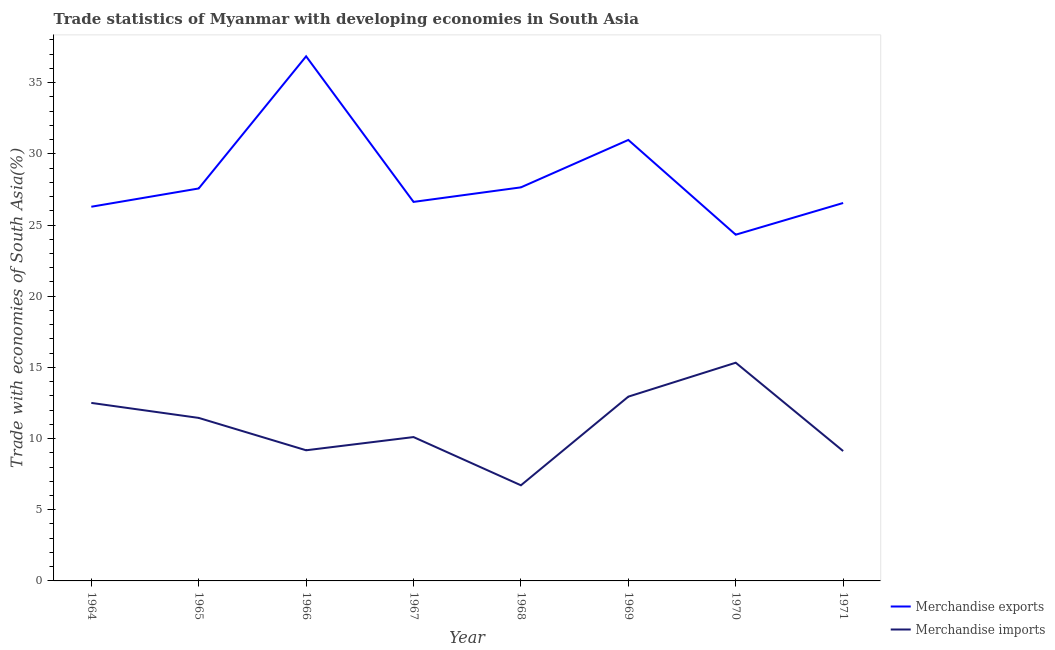How many different coloured lines are there?
Your response must be concise. 2. What is the merchandise exports in 1964?
Make the answer very short. 26.29. Across all years, what is the maximum merchandise exports?
Provide a short and direct response. 36.85. Across all years, what is the minimum merchandise exports?
Offer a very short reply. 24.32. In which year was the merchandise exports maximum?
Make the answer very short. 1966. In which year was the merchandise imports minimum?
Ensure brevity in your answer.  1968. What is the total merchandise exports in the graph?
Give a very brief answer. 226.82. What is the difference between the merchandise exports in 1965 and that in 1970?
Your response must be concise. 3.25. What is the difference between the merchandise imports in 1971 and the merchandise exports in 1964?
Your answer should be compact. -17.16. What is the average merchandise exports per year?
Your answer should be very brief. 28.35. In the year 1969, what is the difference between the merchandise imports and merchandise exports?
Your answer should be compact. -18.03. In how many years, is the merchandise imports greater than 4 %?
Ensure brevity in your answer.  8. What is the ratio of the merchandise exports in 1965 to that in 1969?
Offer a terse response. 0.89. What is the difference between the highest and the second highest merchandise imports?
Provide a short and direct response. 2.38. What is the difference between the highest and the lowest merchandise exports?
Offer a very short reply. 12.53. Does the merchandise exports monotonically increase over the years?
Ensure brevity in your answer.  No. Is the merchandise exports strictly greater than the merchandise imports over the years?
Your response must be concise. Yes. How many lines are there?
Give a very brief answer. 2. How many years are there in the graph?
Your answer should be very brief. 8. What is the difference between two consecutive major ticks on the Y-axis?
Provide a succinct answer. 5. Are the values on the major ticks of Y-axis written in scientific E-notation?
Your answer should be very brief. No. Where does the legend appear in the graph?
Keep it short and to the point. Bottom right. What is the title of the graph?
Offer a very short reply. Trade statistics of Myanmar with developing economies in South Asia. What is the label or title of the X-axis?
Your answer should be compact. Year. What is the label or title of the Y-axis?
Your answer should be very brief. Trade with economies of South Asia(%). What is the Trade with economies of South Asia(%) of Merchandise exports in 1964?
Give a very brief answer. 26.29. What is the Trade with economies of South Asia(%) of Merchandise imports in 1964?
Give a very brief answer. 12.5. What is the Trade with economies of South Asia(%) in Merchandise exports in 1965?
Offer a terse response. 27.57. What is the Trade with economies of South Asia(%) of Merchandise imports in 1965?
Keep it short and to the point. 11.45. What is the Trade with economies of South Asia(%) in Merchandise exports in 1966?
Offer a terse response. 36.85. What is the Trade with economies of South Asia(%) in Merchandise imports in 1966?
Your answer should be very brief. 9.18. What is the Trade with economies of South Asia(%) of Merchandise exports in 1967?
Your answer should be very brief. 26.62. What is the Trade with economies of South Asia(%) in Merchandise imports in 1967?
Your answer should be compact. 10.11. What is the Trade with economies of South Asia(%) in Merchandise exports in 1968?
Your response must be concise. 27.65. What is the Trade with economies of South Asia(%) of Merchandise imports in 1968?
Your answer should be very brief. 6.72. What is the Trade with economies of South Asia(%) of Merchandise exports in 1969?
Your answer should be compact. 30.98. What is the Trade with economies of South Asia(%) in Merchandise imports in 1969?
Your answer should be very brief. 12.94. What is the Trade with economies of South Asia(%) of Merchandise exports in 1970?
Ensure brevity in your answer.  24.32. What is the Trade with economies of South Asia(%) in Merchandise imports in 1970?
Offer a terse response. 15.33. What is the Trade with economies of South Asia(%) in Merchandise exports in 1971?
Provide a short and direct response. 26.55. What is the Trade with economies of South Asia(%) in Merchandise imports in 1971?
Give a very brief answer. 9.12. Across all years, what is the maximum Trade with economies of South Asia(%) of Merchandise exports?
Provide a short and direct response. 36.85. Across all years, what is the maximum Trade with economies of South Asia(%) of Merchandise imports?
Offer a terse response. 15.33. Across all years, what is the minimum Trade with economies of South Asia(%) of Merchandise exports?
Offer a very short reply. 24.32. Across all years, what is the minimum Trade with economies of South Asia(%) of Merchandise imports?
Provide a short and direct response. 6.72. What is the total Trade with economies of South Asia(%) in Merchandise exports in the graph?
Give a very brief answer. 226.82. What is the total Trade with economies of South Asia(%) of Merchandise imports in the graph?
Offer a terse response. 87.35. What is the difference between the Trade with economies of South Asia(%) of Merchandise exports in 1964 and that in 1965?
Provide a short and direct response. -1.28. What is the difference between the Trade with economies of South Asia(%) in Merchandise imports in 1964 and that in 1965?
Your answer should be compact. 1.05. What is the difference between the Trade with economies of South Asia(%) in Merchandise exports in 1964 and that in 1966?
Make the answer very short. -10.57. What is the difference between the Trade with economies of South Asia(%) of Merchandise imports in 1964 and that in 1966?
Your answer should be very brief. 3.33. What is the difference between the Trade with economies of South Asia(%) of Merchandise exports in 1964 and that in 1967?
Your answer should be very brief. -0.34. What is the difference between the Trade with economies of South Asia(%) of Merchandise imports in 1964 and that in 1967?
Provide a short and direct response. 2.4. What is the difference between the Trade with economies of South Asia(%) in Merchandise exports in 1964 and that in 1968?
Give a very brief answer. -1.36. What is the difference between the Trade with economies of South Asia(%) of Merchandise imports in 1964 and that in 1968?
Offer a terse response. 5.79. What is the difference between the Trade with economies of South Asia(%) of Merchandise exports in 1964 and that in 1969?
Ensure brevity in your answer.  -4.69. What is the difference between the Trade with economies of South Asia(%) of Merchandise imports in 1964 and that in 1969?
Offer a very short reply. -0.44. What is the difference between the Trade with economies of South Asia(%) in Merchandise exports in 1964 and that in 1970?
Ensure brevity in your answer.  1.96. What is the difference between the Trade with economies of South Asia(%) of Merchandise imports in 1964 and that in 1970?
Ensure brevity in your answer.  -2.82. What is the difference between the Trade with economies of South Asia(%) in Merchandise exports in 1964 and that in 1971?
Make the answer very short. -0.26. What is the difference between the Trade with economies of South Asia(%) in Merchandise imports in 1964 and that in 1971?
Your answer should be very brief. 3.38. What is the difference between the Trade with economies of South Asia(%) of Merchandise exports in 1965 and that in 1966?
Make the answer very short. -9.28. What is the difference between the Trade with economies of South Asia(%) in Merchandise imports in 1965 and that in 1966?
Keep it short and to the point. 2.27. What is the difference between the Trade with economies of South Asia(%) in Merchandise exports in 1965 and that in 1967?
Keep it short and to the point. 0.94. What is the difference between the Trade with economies of South Asia(%) of Merchandise imports in 1965 and that in 1967?
Provide a short and direct response. 1.35. What is the difference between the Trade with economies of South Asia(%) in Merchandise exports in 1965 and that in 1968?
Your answer should be compact. -0.08. What is the difference between the Trade with economies of South Asia(%) of Merchandise imports in 1965 and that in 1968?
Make the answer very short. 4.73. What is the difference between the Trade with economies of South Asia(%) in Merchandise exports in 1965 and that in 1969?
Ensure brevity in your answer.  -3.41. What is the difference between the Trade with economies of South Asia(%) of Merchandise imports in 1965 and that in 1969?
Provide a succinct answer. -1.49. What is the difference between the Trade with economies of South Asia(%) of Merchandise exports in 1965 and that in 1970?
Make the answer very short. 3.25. What is the difference between the Trade with economies of South Asia(%) of Merchandise imports in 1965 and that in 1970?
Offer a terse response. -3.88. What is the difference between the Trade with economies of South Asia(%) of Merchandise exports in 1965 and that in 1971?
Make the answer very short. 1.02. What is the difference between the Trade with economies of South Asia(%) of Merchandise imports in 1965 and that in 1971?
Give a very brief answer. 2.33. What is the difference between the Trade with economies of South Asia(%) in Merchandise exports in 1966 and that in 1967?
Offer a very short reply. 10.23. What is the difference between the Trade with economies of South Asia(%) in Merchandise imports in 1966 and that in 1967?
Your answer should be compact. -0.93. What is the difference between the Trade with economies of South Asia(%) in Merchandise exports in 1966 and that in 1968?
Provide a short and direct response. 9.2. What is the difference between the Trade with economies of South Asia(%) of Merchandise imports in 1966 and that in 1968?
Give a very brief answer. 2.46. What is the difference between the Trade with economies of South Asia(%) of Merchandise exports in 1966 and that in 1969?
Provide a succinct answer. 5.87. What is the difference between the Trade with economies of South Asia(%) in Merchandise imports in 1966 and that in 1969?
Keep it short and to the point. -3.77. What is the difference between the Trade with economies of South Asia(%) in Merchandise exports in 1966 and that in 1970?
Make the answer very short. 12.53. What is the difference between the Trade with economies of South Asia(%) in Merchandise imports in 1966 and that in 1970?
Your response must be concise. -6.15. What is the difference between the Trade with economies of South Asia(%) of Merchandise exports in 1966 and that in 1971?
Provide a short and direct response. 10.3. What is the difference between the Trade with economies of South Asia(%) in Merchandise imports in 1966 and that in 1971?
Your response must be concise. 0.05. What is the difference between the Trade with economies of South Asia(%) of Merchandise exports in 1967 and that in 1968?
Your answer should be very brief. -1.02. What is the difference between the Trade with economies of South Asia(%) of Merchandise imports in 1967 and that in 1968?
Your response must be concise. 3.39. What is the difference between the Trade with economies of South Asia(%) of Merchandise exports in 1967 and that in 1969?
Offer a terse response. -4.35. What is the difference between the Trade with economies of South Asia(%) of Merchandise imports in 1967 and that in 1969?
Keep it short and to the point. -2.84. What is the difference between the Trade with economies of South Asia(%) in Merchandise exports in 1967 and that in 1970?
Make the answer very short. 2.3. What is the difference between the Trade with economies of South Asia(%) of Merchandise imports in 1967 and that in 1970?
Give a very brief answer. -5.22. What is the difference between the Trade with economies of South Asia(%) of Merchandise exports in 1967 and that in 1971?
Provide a short and direct response. 0.08. What is the difference between the Trade with economies of South Asia(%) of Merchandise imports in 1967 and that in 1971?
Your answer should be compact. 0.98. What is the difference between the Trade with economies of South Asia(%) of Merchandise exports in 1968 and that in 1969?
Offer a terse response. -3.33. What is the difference between the Trade with economies of South Asia(%) of Merchandise imports in 1968 and that in 1969?
Keep it short and to the point. -6.23. What is the difference between the Trade with economies of South Asia(%) in Merchandise exports in 1968 and that in 1970?
Your response must be concise. 3.33. What is the difference between the Trade with economies of South Asia(%) in Merchandise imports in 1968 and that in 1970?
Offer a very short reply. -8.61. What is the difference between the Trade with economies of South Asia(%) of Merchandise exports in 1968 and that in 1971?
Keep it short and to the point. 1.1. What is the difference between the Trade with economies of South Asia(%) in Merchandise imports in 1968 and that in 1971?
Keep it short and to the point. -2.41. What is the difference between the Trade with economies of South Asia(%) in Merchandise exports in 1969 and that in 1970?
Give a very brief answer. 6.66. What is the difference between the Trade with economies of South Asia(%) in Merchandise imports in 1969 and that in 1970?
Your response must be concise. -2.38. What is the difference between the Trade with economies of South Asia(%) of Merchandise exports in 1969 and that in 1971?
Your response must be concise. 4.43. What is the difference between the Trade with economies of South Asia(%) of Merchandise imports in 1969 and that in 1971?
Give a very brief answer. 3.82. What is the difference between the Trade with economies of South Asia(%) in Merchandise exports in 1970 and that in 1971?
Give a very brief answer. -2.23. What is the difference between the Trade with economies of South Asia(%) of Merchandise imports in 1970 and that in 1971?
Your answer should be very brief. 6.21. What is the difference between the Trade with economies of South Asia(%) in Merchandise exports in 1964 and the Trade with economies of South Asia(%) in Merchandise imports in 1965?
Provide a succinct answer. 14.83. What is the difference between the Trade with economies of South Asia(%) of Merchandise exports in 1964 and the Trade with economies of South Asia(%) of Merchandise imports in 1966?
Ensure brevity in your answer.  17.11. What is the difference between the Trade with economies of South Asia(%) of Merchandise exports in 1964 and the Trade with economies of South Asia(%) of Merchandise imports in 1967?
Provide a succinct answer. 16.18. What is the difference between the Trade with economies of South Asia(%) in Merchandise exports in 1964 and the Trade with economies of South Asia(%) in Merchandise imports in 1968?
Your response must be concise. 19.57. What is the difference between the Trade with economies of South Asia(%) in Merchandise exports in 1964 and the Trade with economies of South Asia(%) in Merchandise imports in 1969?
Offer a terse response. 13.34. What is the difference between the Trade with economies of South Asia(%) in Merchandise exports in 1964 and the Trade with economies of South Asia(%) in Merchandise imports in 1970?
Make the answer very short. 10.96. What is the difference between the Trade with economies of South Asia(%) in Merchandise exports in 1964 and the Trade with economies of South Asia(%) in Merchandise imports in 1971?
Make the answer very short. 17.16. What is the difference between the Trade with economies of South Asia(%) in Merchandise exports in 1965 and the Trade with economies of South Asia(%) in Merchandise imports in 1966?
Provide a succinct answer. 18.39. What is the difference between the Trade with economies of South Asia(%) of Merchandise exports in 1965 and the Trade with economies of South Asia(%) of Merchandise imports in 1967?
Offer a very short reply. 17.46. What is the difference between the Trade with economies of South Asia(%) of Merchandise exports in 1965 and the Trade with economies of South Asia(%) of Merchandise imports in 1968?
Your answer should be compact. 20.85. What is the difference between the Trade with economies of South Asia(%) in Merchandise exports in 1965 and the Trade with economies of South Asia(%) in Merchandise imports in 1969?
Offer a terse response. 14.62. What is the difference between the Trade with economies of South Asia(%) in Merchandise exports in 1965 and the Trade with economies of South Asia(%) in Merchandise imports in 1970?
Provide a succinct answer. 12.24. What is the difference between the Trade with economies of South Asia(%) of Merchandise exports in 1965 and the Trade with economies of South Asia(%) of Merchandise imports in 1971?
Offer a very short reply. 18.45. What is the difference between the Trade with economies of South Asia(%) of Merchandise exports in 1966 and the Trade with economies of South Asia(%) of Merchandise imports in 1967?
Ensure brevity in your answer.  26.75. What is the difference between the Trade with economies of South Asia(%) of Merchandise exports in 1966 and the Trade with economies of South Asia(%) of Merchandise imports in 1968?
Ensure brevity in your answer.  30.13. What is the difference between the Trade with economies of South Asia(%) of Merchandise exports in 1966 and the Trade with economies of South Asia(%) of Merchandise imports in 1969?
Offer a terse response. 23.91. What is the difference between the Trade with economies of South Asia(%) in Merchandise exports in 1966 and the Trade with economies of South Asia(%) in Merchandise imports in 1970?
Your answer should be compact. 21.52. What is the difference between the Trade with economies of South Asia(%) of Merchandise exports in 1966 and the Trade with economies of South Asia(%) of Merchandise imports in 1971?
Give a very brief answer. 27.73. What is the difference between the Trade with economies of South Asia(%) of Merchandise exports in 1967 and the Trade with economies of South Asia(%) of Merchandise imports in 1968?
Your response must be concise. 19.91. What is the difference between the Trade with economies of South Asia(%) in Merchandise exports in 1967 and the Trade with economies of South Asia(%) in Merchandise imports in 1969?
Provide a short and direct response. 13.68. What is the difference between the Trade with economies of South Asia(%) in Merchandise exports in 1967 and the Trade with economies of South Asia(%) in Merchandise imports in 1970?
Offer a very short reply. 11.3. What is the difference between the Trade with economies of South Asia(%) in Merchandise exports in 1967 and the Trade with economies of South Asia(%) in Merchandise imports in 1971?
Your answer should be compact. 17.5. What is the difference between the Trade with economies of South Asia(%) of Merchandise exports in 1968 and the Trade with economies of South Asia(%) of Merchandise imports in 1969?
Provide a short and direct response. 14.7. What is the difference between the Trade with economies of South Asia(%) in Merchandise exports in 1968 and the Trade with economies of South Asia(%) in Merchandise imports in 1970?
Make the answer very short. 12.32. What is the difference between the Trade with economies of South Asia(%) of Merchandise exports in 1968 and the Trade with economies of South Asia(%) of Merchandise imports in 1971?
Give a very brief answer. 18.52. What is the difference between the Trade with economies of South Asia(%) in Merchandise exports in 1969 and the Trade with economies of South Asia(%) in Merchandise imports in 1970?
Your answer should be very brief. 15.65. What is the difference between the Trade with economies of South Asia(%) of Merchandise exports in 1969 and the Trade with economies of South Asia(%) of Merchandise imports in 1971?
Make the answer very short. 21.85. What is the difference between the Trade with economies of South Asia(%) of Merchandise exports in 1970 and the Trade with economies of South Asia(%) of Merchandise imports in 1971?
Your answer should be compact. 15.2. What is the average Trade with economies of South Asia(%) in Merchandise exports per year?
Give a very brief answer. 28.35. What is the average Trade with economies of South Asia(%) of Merchandise imports per year?
Your answer should be compact. 10.92. In the year 1964, what is the difference between the Trade with economies of South Asia(%) of Merchandise exports and Trade with economies of South Asia(%) of Merchandise imports?
Keep it short and to the point. 13.78. In the year 1965, what is the difference between the Trade with economies of South Asia(%) of Merchandise exports and Trade with economies of South Asia(%) of Merchandise imports?
Provide a short and direct response. 16.12. In the year 1966, what is the difference between the Trade with economies of South Asia(%) of Merchandise exports and Trade with economies of South Asia(%) of Merchandise imports?
Offer a very short reply. 27.67. In the year 1967, what is the difference between the Trade with economies of South Asia(%) of Merchandise exports and Trade with economies of South Asia(%) of Merchandise imports?
Your answer should be compact. 16.52. In the year 1968, what is the difference between the Trade with economies of South Asia(%) of Merchandise exports and Trade with economies of South Asia(%) of Merchandise imports?
Provide a short and direct response. 20.93. In the year 1969, what is the difference between the Trade with economies of South Asia(%) in Merchandise exports and Trade with economies of South Asia(%) in Merchandise imports?
Your answer should be very brief. 18.03. In the year 1970, what is the difference between the Trade with economies of South Asia(%) of Merchandise exports and Trade with economies of South Asia(%) of Merchandise imports?
Ensure brevity in your answer.  8.99. In the year 1971, what is the difference between the Trade with economies of South Asia(%) of Merchandise exports and Trade with economies of South Asia(%) of Merchandise imports?
Keep it short and to the point. 17.42. What is the ratio of the Trade with economies of South Asia(%) in Merchandise exports in 1964 to that in 1965?
Keep it short and to the point. 0.95. What is the ratio of the Trade with economies of South Asia(%) of Merchandise imports in 1964 to that in 1965?
Make the answer very short. 1.09. What is the ratio of the Trade with economies of South Asia(%) in Merchandise exports in 1964 to that in 1966?
Keep it short and to the point. 0.71. What is the ratio of the Trade with economies of South Asia(%) of Merchandise imports in 1964 to that in 1966?
Keep it short and to the point. 1.36. What is the ratio of the Trade with economies of South Asia(%) of Merchandise exports in 1964 to that in 1967?
Provide a succinct answer. 0.99. What is the ratio of the Trade with economies of South Asia(%) in Merchandise imports in 1964 to that in 1967?
Keep it short and to the point. 1.24. What is the ratio of the Trade with economies of South Asia(%) in Merchandise exports in 1964 to that in 1968?
Your answer should be very brief. 0.95. What is the ratio of the Trade with economies of South Asia(%) of Merchandise imports in 1964 to that in 1968?
Keep it short and to the point. 1.86. What is the ratio of the Trade with economies of South Asia(%) of Merchandise exports in 1964 to that in 1969?
Your response must be concise. 0.85. What is the ratio of the Trade with economies of South Asia(%) in Merchandise exports in 1964 to that in 1970?
Provide a succinct answer. 1.08. What is the ratio of the Trade with economies of South Asia(%) in Merchandise imports in 1964 to that in 1970?
Provide a succinct answer. 0.82. What is the ratio of the Trade with economies of South Asia(%) of Merchandise exports in 1964 to that in 1971?
Your answer should be compact. 0.99. What is the ratio of the Trade with economies of South Asia(%) in Merchandise imports in 1964 to that in 1971?
Provide a short and direct response. 1.37. What is the ratio of the Trade with economies of South Asia(%) in Merchandise exports in 1965 to that in 1966?
Offer a very short reply. 0.75. What is the ratio of the Trade with economies of South Asia(%) of Merchandise imports in 1965 to that in 1966?
Your answer should be compact. 1.25. What is the ratio of the Trade with economies of South Asia(%) of Merchandise exports in 1965 to that in 1967?
Offer a terse response. 1.04. What is the ratio of the Trade with economies of South Asia(%) in Merchandise imports in 1965 to that in 1967?
Offer a very short reply. 1.13. What is the ratio of the Trade with economies of South Asia(%) in Merchandise imports in 1965 to that in 1968?
Your answer should be very brief. 1.7. What is the ratio of the Trade with economies of South Asia(%) of Merchandise exports in 1965 to that in 1969?
Your answer should be compact. 0.89. What is the ratio of the Trade with economies of South Asia(%) of Merchandise imports in 1965 to that in 1969?
Your response must be concise. 0.88. What is the ratio of the Trade with economies of South Asia(%) of Merchandise exports in 1965 to that in 1970?
Ensure brevity in your answer.  1.13. What is the ratio of the Trade with economies of South Asia(%) of Merchandise imports in 1965 to that in 1970?
Keep it short and to the point. 0.75. What is the ratio of the Trade with economies of South Asia(%) of Merchandise exports in 1965 to that in 1971?
Keep it short and to the point. 1.04. What is the ratio of the Trade with economies of South Asia(%) of Merchandise imports in 1965 to that in 1971?
Provide a succinct answer. 1.26. What is the ratio of the Trade with economies of South Asia(%) of Merchandise exports in 1966 to that in 1967?
Your answer should be compact. 1.38. What is the ratio of the Trade with economies of South Asia(%) of Merchandise imports in 1966 to that in 1967?
Give a very brief answer. 0.91. What is the ratio of the Trade with economies of South Asia(%) in Merchandise exports in 1966 to that in 1968?
Your response must be concise. 1.33. What is the ratio of the Trade with economies of South Asia(%) in Merchandise imports in 1966 to that in 1968?
Your response must be concise. 1.37. What is the ratio of the Trade with economies of South Asia(%) of Merchandise exports in 1966 to that in 1969?
Provide a succinct answer. 1.19. What is the ratio of the Trade with economies of South Asia(%) in Merchandise imports in 1966 to that in 1969?
Ensure brevity in your answer.  0.71. What is the ratio of the Trade with economies of South Asia(%) of Merchandise exports in 1966 to that in 1970?
Provide a succinct answer. 1.52. What is the ratio of the Trade with economies of South Asia(%) in Merchandise imports in 1966 to that in 1970?
Your answer should be very brief. 0.6. What is the ratio of the Trade with economies of South Asia(%) of Merchandise exports in 1966 to that in 1971?
Make the answer very short. 1.39. What is the ratio of the Trade with economies of South Asia(%) of Merchandise imports in 1966 to that in 1971?
Give a very brief answer. 1.01. What is the ratio of the Trade with economies of South Asia(%) in Merchandise exports in 1967 to that in 1968?
Your response must be concise. 0.96. What is the ratio of the Trade with economies of South Asia(%) in Merchandise imports in 1967 to that in 1968?
Your response must be concise. 1.5. What is the ratio of the Trade with economies of South Asia(%) of Merchandise exports in 1967 to that in 1969?
Keep it short and to the point. 0.86. What is the ratio of the Trade with economies of South Asia(%) of Merchandise imports in 1967 to that in 1969?
Keep it short and to the point. 0.78. What is the ratio of the Trade with economies of South Asia(%) in Merchandise exports in 1967 to that in 1970?
Make the answer very short. 1.09. What is the ratio of the Trade with economies of South Asia(%) of Merchandise imports in 1967 to that in 1970?
Give a very brief answer. 0.66. What is the ratio of the Trade with economies of South Asia(%) of Merchandise imports in 1967 to that in 1971?
Provide a succinct answer. 1.11. What is the ratio of the Trade with economies of South Asia(%) in Merchandise exports in 1968 to that in 1969?
Your answer should be very brief. 0.89. What is the ratio of the Trade with economies of South Asia(%) of Merchandise imports in 1968 to that in 1969?
Offer a very short reply. 0.52. What is the ratio of the Trade with economies of South Asia(%) of Merchandise exports in 1968 to that in 1970?
Your answer should be very brief. 1.14. What is the ratio of the Trade with economies of South Asia(%) in Merchandise imports in 1968 to that in 1970?
Make the answer very short. 0.44. What is the ratio of the Trade with economies of South Asia(%) in Merchandise exports in 1968 to that in 1971?
Ensure brevity in your answer.  1.04. What is the ratio of the Trade with economies of South Asia(%) of Merchandise imports in 1968 to that in 1971?
Make the answer very short. 0.74. What is the ratio of the Trade with economies of South Asia(%) in Merchandise exports in 1969 to that in 1970?
Your response must be concise. 1.27. What is the ratio of the Trade with economies of South Asia(%) in Merchandise imports in 1969 to that in 1970?
Make the answer very short. 0.84. What is the ratio of the Trade with economies of South Asia(%) of Merchandise exports in 1969 to that in 1971?
Provide a succinct answer. 1.17. What is the ratio of the Trade with economies of South Asia(%) in Merchandise imports in 1969 to that in 1971?
Provide a short and direct response. 1.42. What is the ratio of the Trade with economies of South Asia(%) in Merchandise exports in 1970 to that in 1971?
Provide a short and direct response. 0.92. What is the ratio of the Trade with economies of South Asia(%) in Merchandise imports in 1970 to that in 1971?
Offer a terse response. 1.68. What is the difference between the highest and the second highest Trade with economies of South Asia(%) of Merchandise exports?
Your answer should be very brief. 5.87. What is the difference between the highest and the second highest Trade with economies of South Asia(%) of Merchandise imports?
Your answer should be very brief. 2.38. What is the difference between the highest and the lowest Trade with economies of South Asia(%) of Merchandise exports?
Offer a terse response. 12.53. What is the difference between the highest and the lowest Trade with economies of South Asia(%) in Merchandise imports?
Keep it short and to the point. 8.61. 